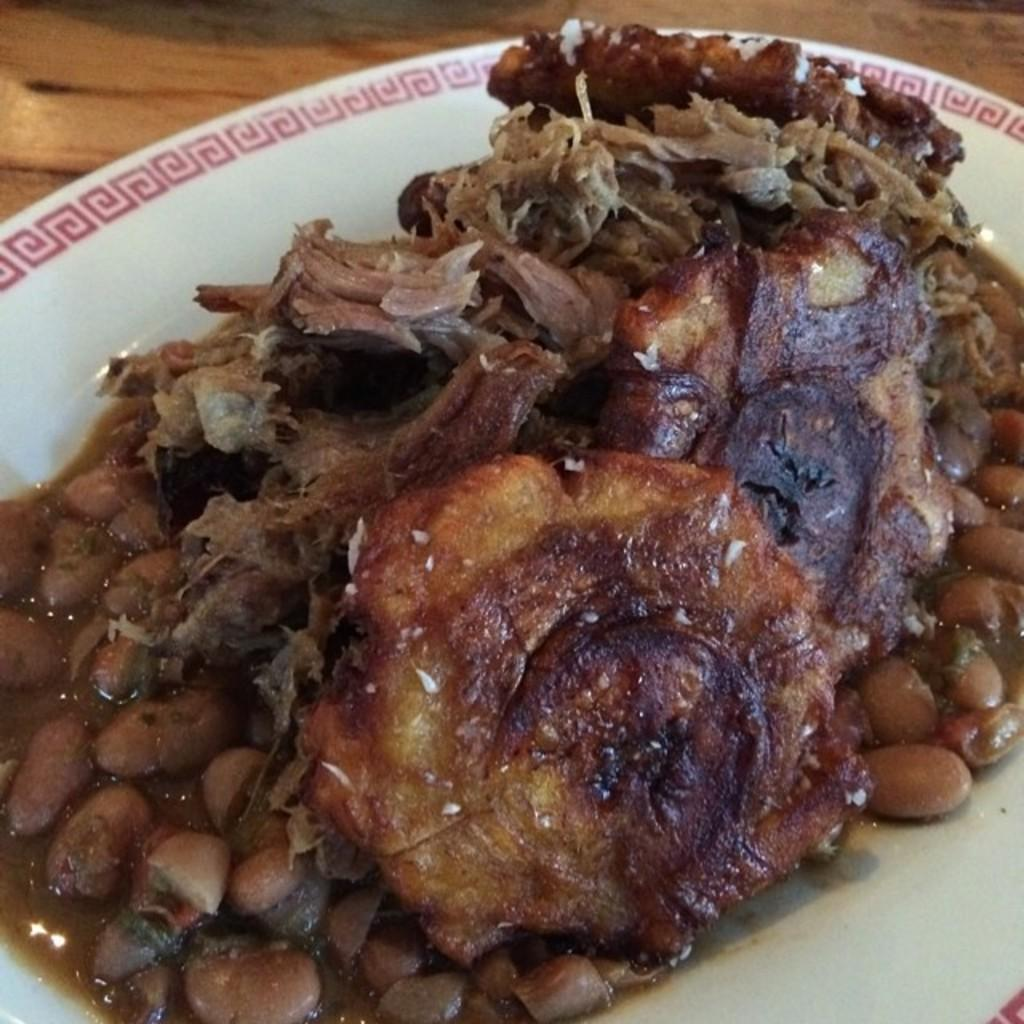What is on the white plate in the image? There is food on a white plate in the image. What piece of furniture is visible in the image? There is a table in the image. How many pigs are wearing underwear in the image? There are no pigs or underwear present in the image. 